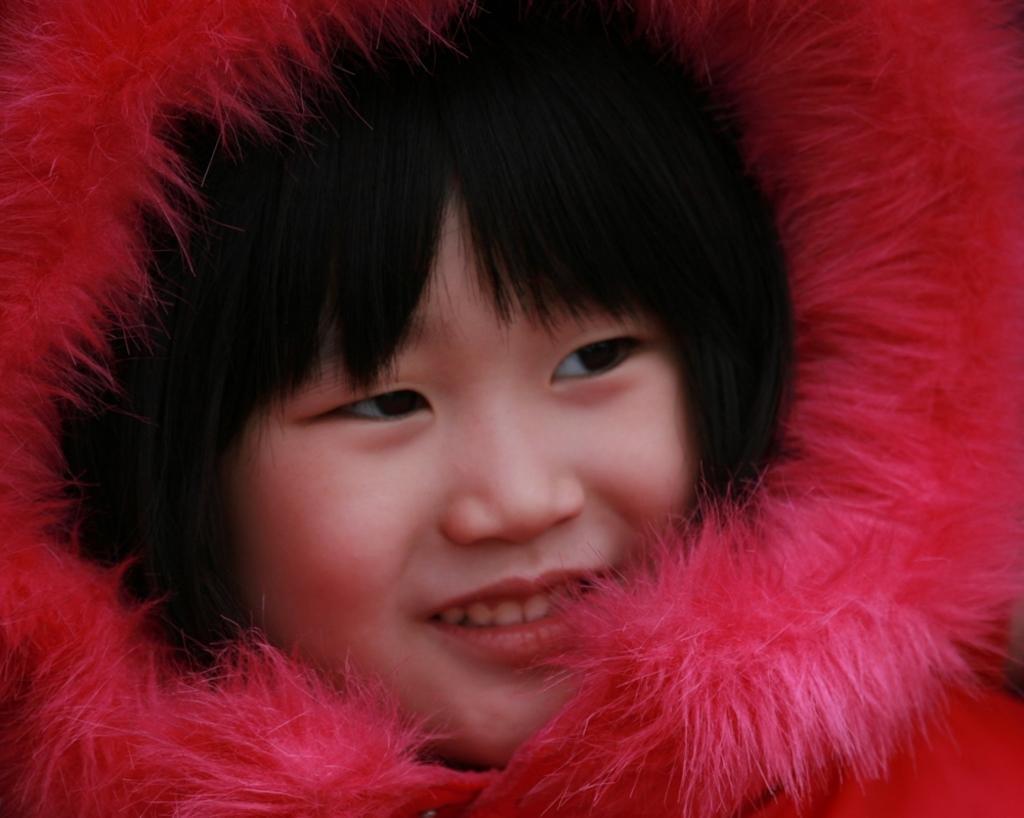Who is the main subject in the image? There is a girl in the image. What is the girl doing in the image? The girl is smiling in the image. What is the girl wearing in the image? The girl is wearing a sweater in the image. What type of cap is the girl wearing in the image? There is no cap visible in the image; the girl is wearing a sweater. How does the girl start her day in the image? The image does not show the girl starting her day or any activities related to starting her day. 